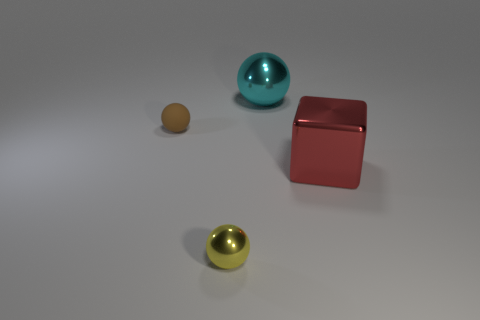Subtract all brown spheres. Subtract all cyan blocks. How many spheres are left? 2 Add 2 red blocks. How many objects exist? 6 Subtract all cubes. How many objects are left? 3 Subtract 1 brown spheres. How many objects are left? 3 Subtract all small purple matte cylinders. Subtract all yellow shiny objects. How many objects are left? 3 Add 2 small brown things. How many small brown things are left? 3 Add 2 small metal blocks. How many small metal blocks exist? 2 